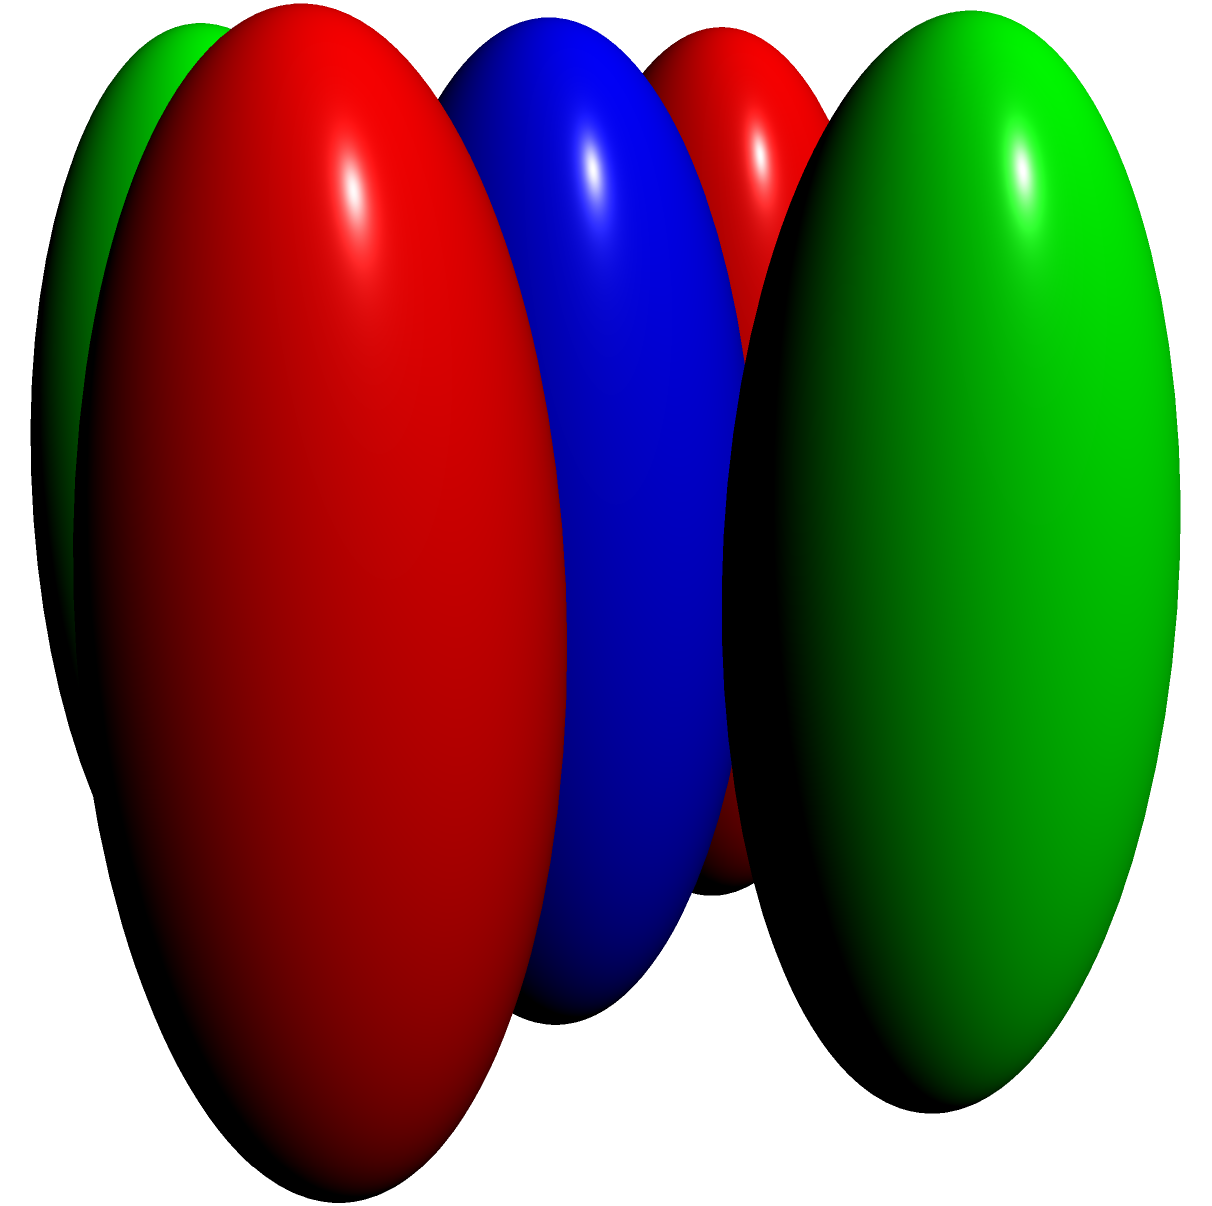As a pharmacist familiar with molecular structures, consider the symmetry of the molecule shown above. The central atom X is bonded to two Y atoms and two Z atoms in a square planar arrangement. What is the point group of this molecule, and how many symmetry operations does it have? To determine the point group and number of symmetry operations, let's analyze the molecule step-by-step:

1. Identify symmetry elements:
   a) $C_4$ axis: 4-fold rotation axis through the central X atom, perpendicular to the plane.
   b) $C_2$ axis: 2-fold rotation axis through the central X atom, in the plane.
   c) 4 $\sigma_v$ planes: vertical mirror planes containing the X-Y and X-Z bonds.
   d) $\sigma_h$ plane: horizontal mirror plane containing all atoms.

2. Determine the point group:
   The presence of a $C_4$ axis, multiple $\sigma_v$ planes, and a $\sigma_h$ plane indicates that this molecule belongs to the $D_{4h}$ point group.

3. Count symmetry operations:
   a) $E$ (identity): 1
   b) $C_4$ and $C_4^3$: 2
   c) $C_2$ (along $C_4$ axis): 1
   d) $2C_2'$ (perpendicular to $C_4$ axis): 2
   e) $2C_2''$ (45° to $C_2'$): 2
   f) $i$ (inversion): 1
   g) $S_4$ and $S_4^3$: 2
   h) $\sigma_h$: 1
   i) $2\sigma_v$: 2
   j) $2\sigma_d$: 2

   Total number of symmetry operations: 16

Therefore, the molecule belongs to the $D_{4h}$ point group and has 16 symmetry operations.
Answer: $D_{4h}$, 16 symmetry operations 